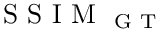<formula> <loc_0><loc_0><loc_500><loc_500>S S I M _ { G T }</formula> 